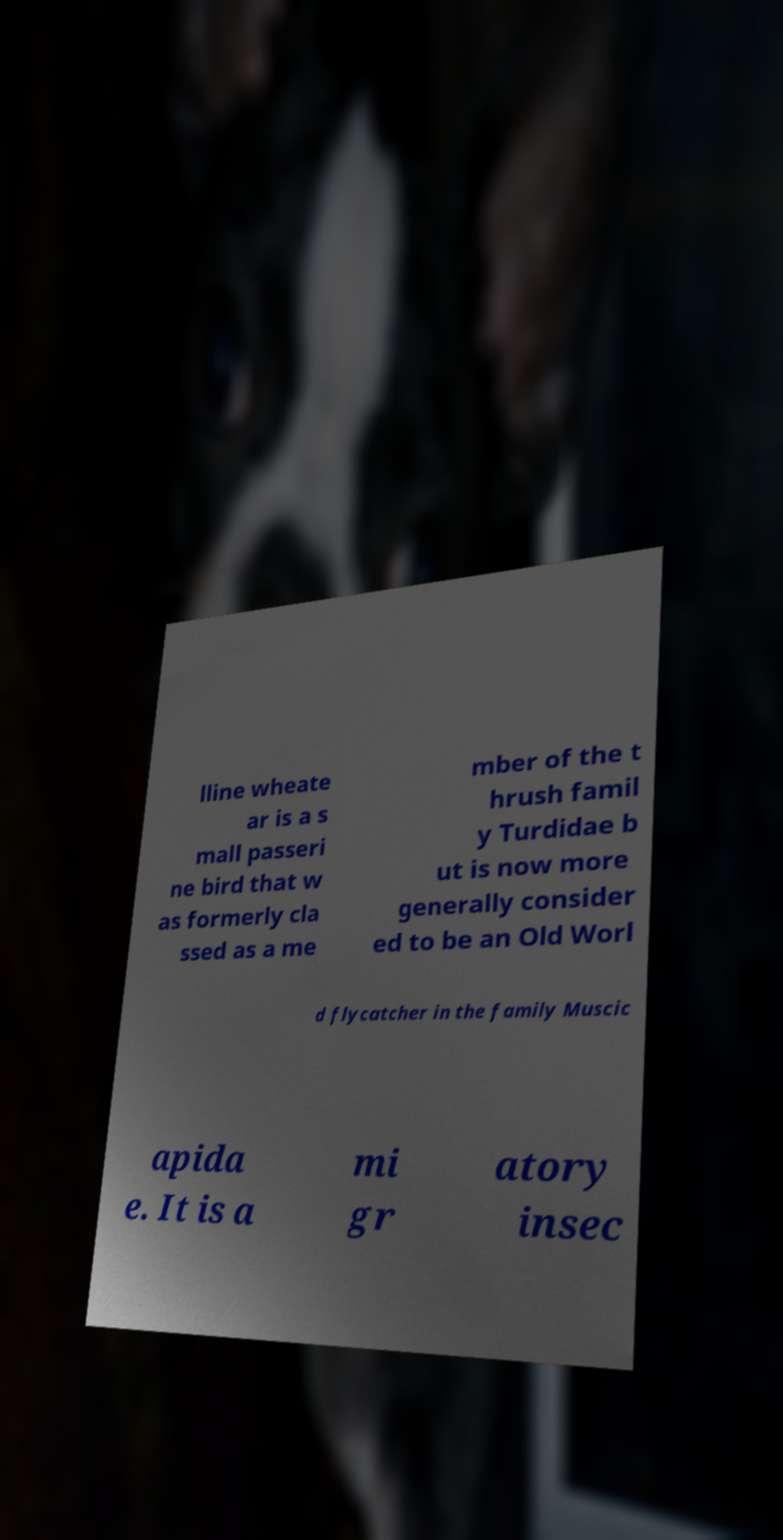For documentation purposes, I need the text within this image transcribed. Could you provide that? lline wheate ar is a s mall passeri ne bird that w as formerly cla ssed as a me mber of the t hrush famil y Turdidae b ut is now more generally consider ed to be an Old Worl d flycatcher in the family Muscic apida e. It is a mi gr atory insec 